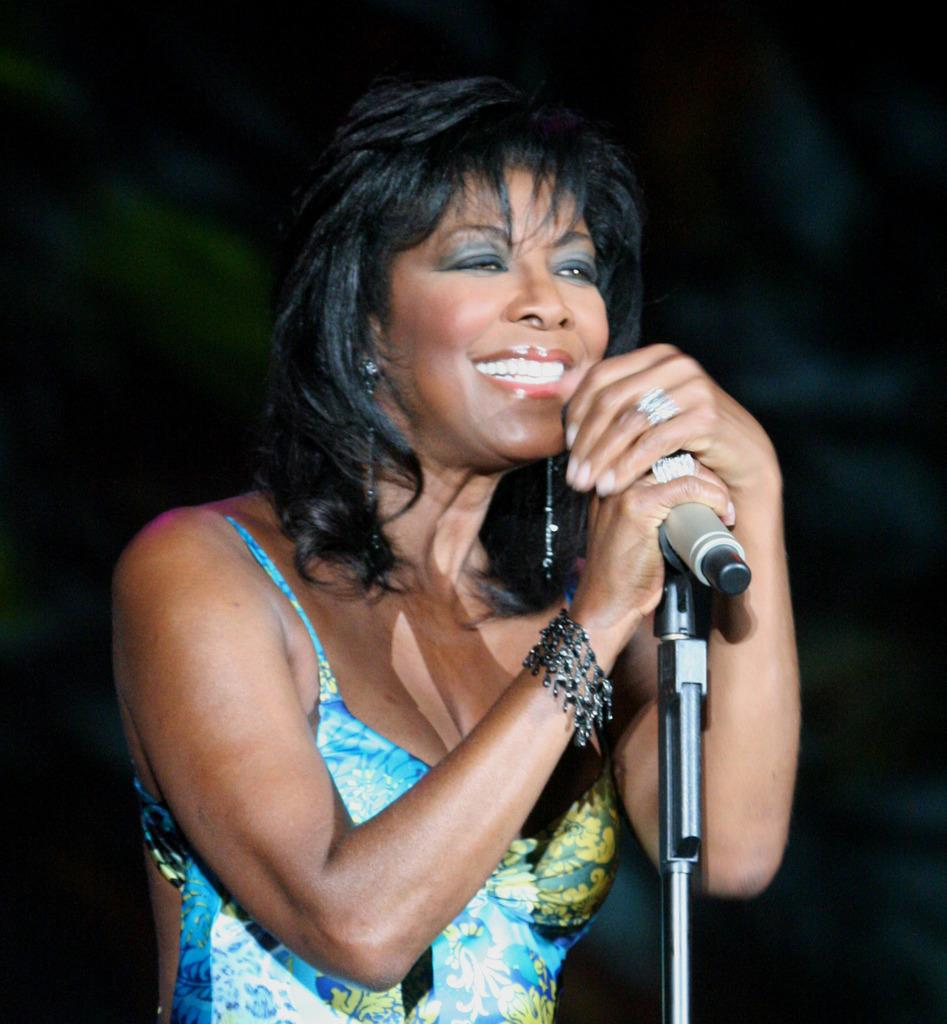Who is the main subject in the image? There is a woman in the image. What is the woman doing in the image? The woman is standing and smiling. What object is the woman holding in her hands? The woman is holding a microphone in her hands. What other object related to the microphone can be seen in the image? There is a microphone stand in the image. What flavor of ice cream is the woman holding in her hands? The woman is not holding ice cream in her hands; she is holding a microphone. 